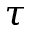<formula> <loc_0><loc_0><loc_500><loc_500>\tau</formula> 